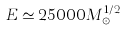Convert formula to latex. <formula><loc_0><loc_0><loc_500><loc_500>E \simeq 2 5 0 0 0 M _ { \odot } ^ { 1 / 2 }</formula> 